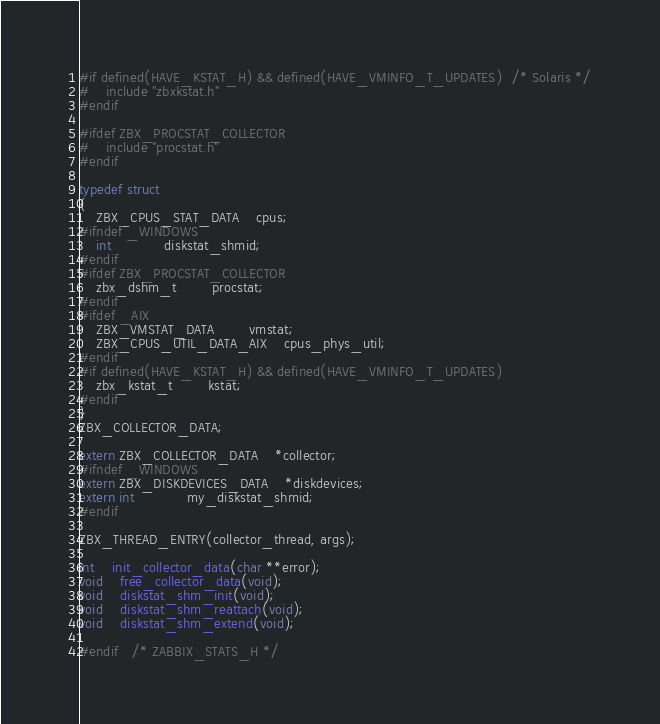Convert code to text. <code><loc_0><loc_0><loc_500><loc_500><_C_>#if defined(HAVE_KSTAT_H) && defined(HAVE_VMINFO_T_UPDATES)	/* Solaris */
#	include "zbxkstat.h"
#endif

#ifdef ZBX_PROCSTAT_COLLECTOR
#	include "procstat.h"
#endif

typedef struct
{
	ZBX_CPUS_STAT_DATA	cpus;
#ifndef _WINDOWS
	int 			diskstat_shmid;
#endif
#ifdef ZBX_PROCSTAT_COLLECTOR
	zbx_dshm_t		procstat;
#endif
#ifdef _AIX
	ZBX_VMSTAT_DATA		vmstat;
	ZBX_CPUS_UTIL_DATA_AIX	cpus_phys_util;
#endif
#if defined(HAVE_KSTAT_H) && defined(HAVE_VMINFO_T_UPDATES)
	zbx_kstat_t		kstat;
#endif
}
ZBX_COLLECTOR_DATA;

extern ZBX_COLLECTOR_DATA	*collector;
#ifndef _WINDOWS
extern ZBX_DISKDEVICES_DATA	*diskdevices;
extern int			my_diskstat_shmid;
#endif

ZBX_THREAD_ENTRY(collector_thread, args);

int	init_collector_data(char **error);
void	free_collector_data(void);
void	diskstat_shm_init(void);
void	diskstat_shm_reattach(void);
void	diskstat_shm_extend(void);

#endif	/* ZABBIX_STATS_H */
</code> 